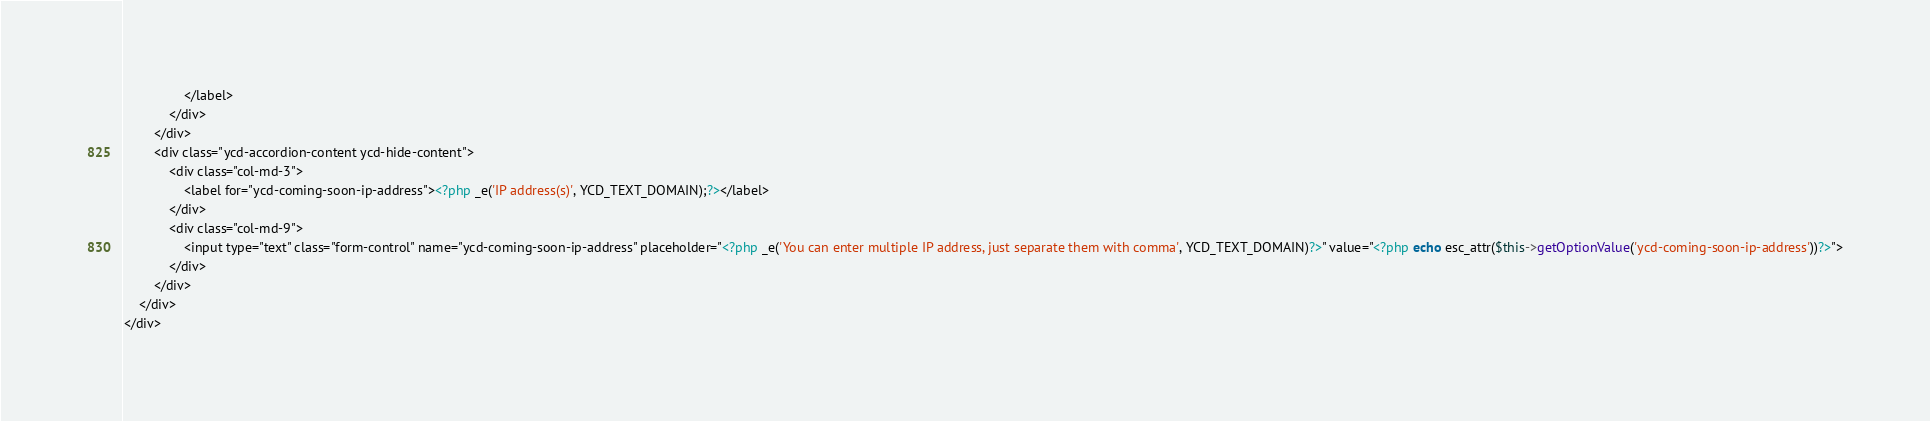<code> <loc_0><loc_0><loc_500><loc_500><_PHP_>				</label>
			</div>
		</div>
		<div class="ycd-accordion-content ycd-hide-content">
			<div class="col-md-3">
				<label for="ycd-coming-soon-ip-address"><?php _e('IP address(s)', YCD_TEXT_DOMAIN);?></label>
			</div>
			<div class="col-md-9">
				<input type="text" class="form-control" name="ycd-coming-soon-ip-address" placeholder="<?php _e('You can enter multiple IP address, just separate them with comma', YCD_TEXT_DOMAIN)?>" value="<?php echo esc_attr($this->getOptionValue('ycd-coming-soon-ip-address'))?>">
			</div>
		</div>
	</div>
</div></code> 